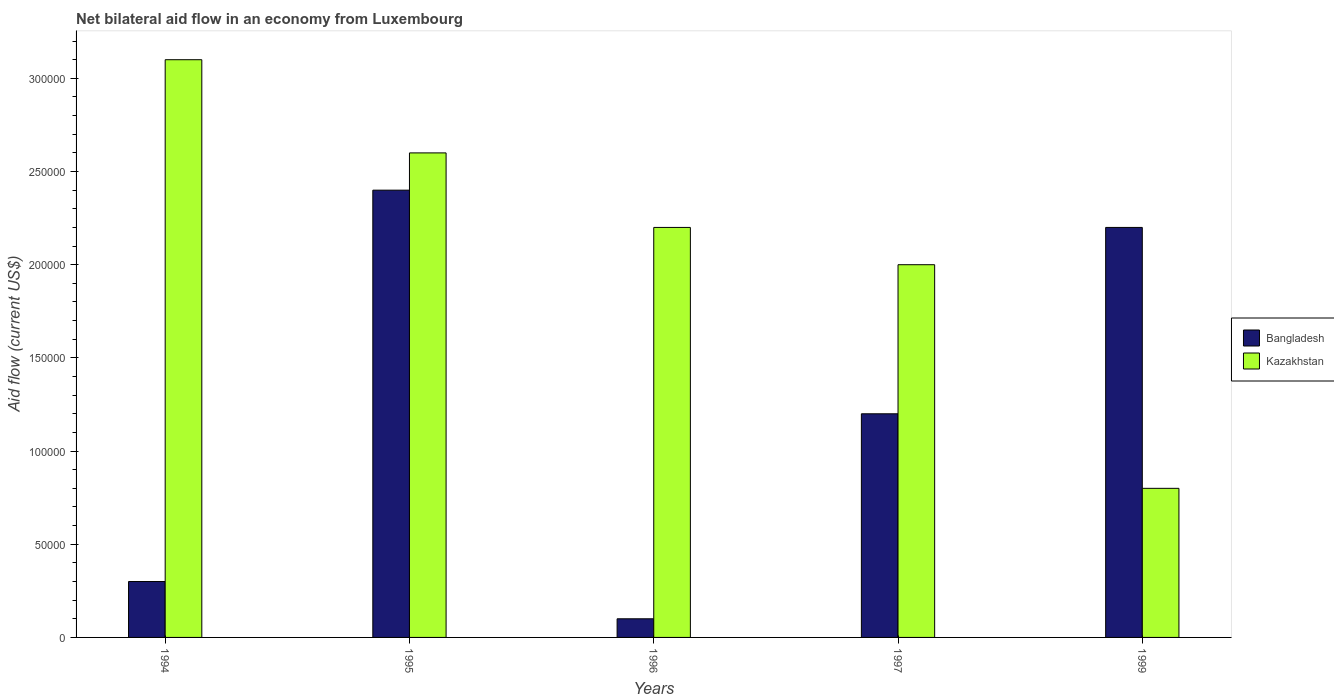How many different coloured bars are there?
Your answer should be very brief. 2. How many groups of bars are there?
Your answer should be very brief. 5. How many bars are there on the 4th tick from the left?
Provide a short and direct response. 2. What is the label of the 4th group of bars from the left?
Give a very brief answer. 1997. Across all years, what is the maximum net bilateral aid flow in Bangladesh?
Your answer should be very brief. 2.40e+05. Across all years, what is the minimum net bilateral aid flow in Bangladesh?
Your response must be concise. 10000. In which year was the net bilateral aid flow in Bangladesh maximum?
Keep it short and to the point. 1995. In which year was the net bilateral aid flow in Kazakhstan minimum?
Your answer should be very brief. 1999. What is the total net bilateral aid flow in Kazakhstan in the graph?
Provide a short and direct response. 1.07e+06. What is the difference between the net bilateral aid flow in Bangladesh in 1997 and the net bilateral aid flow in Kazakhstan in 1994?
Give a very brief answer. -1.90e+05. What is the average net bilateral aid flow in Kazakhstan per year?
Your answer should be very brief. 2.14e+05. In the year 1999, what is the difference between the net bilateral aid flow in Kazakhstan and net bilateral aid flow in Bangladesh?
Give a very brief answer. -1.40e+05. In how many years, is the net bilateral aid flow in Kazakhstan greater than 250000 US$?
Your answer should be very brief. 2. What is the ratio of the net bilateral aid flow in Kazakhstan in 1995 to that in 1996?
Keep it short and to the point. 1.18. What does the 2nd bar from the right in 1995 represents?
Your answer should be compact. Bangladesh. How many years are there in the graph?
Your answer should be very brief. 5. What is the difference between two consecutive major ticks on the Y-axis?
Keep it short and to the point. 5.00e+04. Are the values on the major ticks of Y-axis written in scientific E-notation?
Give a very brief answer. No. Does the graph contain any zero values?
Offer a terse response. No. Where does the legend appear in the graph?
Give a very brief answer. Center right. How are the legend labels stacked?
Offer a terse response. Vertical. What is the title of the graph?
Offer a very short reply. Net bilateral aid flow in an economy from Luxembourg. What is the label or title of the X-axis?
Your response must be concise. Years. What is the Aid flow (current US$) of Bangladesh in 1994?
Provide a short and direct response. 3.00e+04. What is the Aid flow (current US$) in Bangladesh in 1995?
Offer a very short reply. 2.40e+05. What is the Aid flow (current US$) of Kazakhstan in 1996?
Offer a very short reply. 2.20e+05. What is the Aid flow (current US$) in Bangladesh in 1997?
Give a very brief answer. 1.20e+05. What is the Aid flow (current US$) in Kazakhstan in 1999?
Provide a short and direct response. 8.00e+04. Across all years, what is the maximum Aid flow (current US$) in Kazakhstan?
Ensure brevity in your answer.  3.10e+05. Across all years, what is the minimum Aid flow (current US$) of Bangladesh?
Provide a short and direct response. 10000. What is the total Aid flow (current US$) of Bangladesh in the graph?
Give a very brief answer. 6.20e+05. What is the total Aid flow (current US$) in Kazakhstan in the graph?
Your response must be concise. 1.07e+06. What is the difference between the Aid flow (current US$) of Bangladesh in 1994 and that in 1996?
Offer a terse response. 2.00e+04. What is the difference between the Aid flow (current US$) in Kazakhstan in 1994 and that in 1999?
Provide a short and direct response. 2.30e+05. What is the difference between the Aid flow (current US$) of Kazakhstan in 1995 and that in 1996?
Your response must be concise. 4.00e+04. What is the difference between the Aid flow (current US$) of Bangladesh in 1995 and that in 1997?
Give a very brief answer. 1.20e+05. What is the difference between the Aid flow (current US$) in Kazakhstan in 1995 and that in 1999?
Make the answer very short. 1.80e+05. What is the difference between the Aid flow (current US$) of Bangladesh in 1996 and that in 1997?
Offer a terse response. -1.10e+05. What is the difference between the Aid flow (current US$) in Kazakhstan in 1996 and that in 1997?
Your response must be concise. 2.00e+04. What is the difference between the Aid flow (current US$) of Kazakhstan in 1996 and that in 1999?
Offer a very short reply. 1.40e+05. What is the difference between the Aid flow (current US$) of Bangladesh in 1994 and the Aid flow (current US$) of Kazakhstan in 1996?
Your response must be concise. -1.90e+05. What is the difference between the Aid flow (current US$) of Bangladesh in 1994 and the Aid flow (current US$) of Kazakhstan in 1997?
Offer a very short reply. -1.70e+05. What is the difference between the Aid flow (current US$) in Bangladesh in 1996 and the Aid flow (current US$) in Kazakhstan in 1997?
Offer a very short reply. -1.90e+05. What is the difference between the Aid flow (current US$) in Bangladesh in 1996 and the Aid flow (current US$) in Kazakhstan in 1999?
Your answer should be very brief. -7.00e+04. What is the difference between the Aid flow (current US$) in Bangladesh in 1997 and the Aid flow (current US$) in Kazakhstan in 1999?
Provide a short and direct response. 4.00e+04. What is the average Aid flow (current US$) in Bangladesh per year?
Your response must be concise. 1.24e+05. What is the average Aid flow (current US$) in Kazakhstan per year?
Your answer should be very brief. 2.14e+05. In the year 1994, what is the difference between the Aid flow (current US$) in Bangladesh and Aid flow (current US$) in Kazakhstan?
Keep it short and to the point. -2.80e+05. In the year 1996, what is the difference between the Aid flow (current US$) in Bangladesh and Aid flow (current US$) in Kazakhstan?
Offer a terse response. -2.10e+05. In the year 1997, what is the difference between the Aid flow (current US$) in Bangladesh and Aid flow (current US$) in Kazakhstan?
Make the answer very short. -8.00e+04. What is the ratio of the Aid flow (current US$) in Kazakhstan in 1994 to that in 1995?
Provide a succinct answer. 1.19. What is the ratio of the Aid flow (current US$) of Kazakhstan in 1994 to that in 1996?
Your response must be concise. 1.41. What is the ratio of the Aid flow (current US$) of Kazakhstan in 1994 to that in 1997?
Your answer should be compact. 1.55. What is the ratio of the Aid flow (current US$) in Bangladesh in 1994 to that in 1999?
Your response must be concise. 0.14. What is the ratio of the Aid flow (current US$) in Kazakhstan in 1994 to that in 1999?
Give a very brief answer. 3.88. What is the ratio of the Aid flow (current US$) of Kazakhstan in 1995 to that in 1996?
Give a very brief answer. 1.18. What is the ratio of the Aid flow (current US$) of Bangladesh in 1995 to that in 1997?
Ensure brevity in your answer.  2. What is the ratio of the Aid flow (current US$) of Kazakhstan in 1995 to that in 1997?
Provide a succinct answer. 1.3. What is the ratio of the Aid flow (current US$) of Bangladesh in 1995 to that in 1999?
Offer a terse response. 1.09. What is the ratio of the Aid flow (current US$) of Bangladesh in 1996 to that in 1997?
Ensure brevity in your answer.  0.08. What is the ratio of the Aid flow (current US$) in Bangladesh in 1996 to that in 1999?
Offer a terse response. 0.05. What is the ratio of the Aid flow (current US$) of Kazakhstan in 1996 to that in 1999?
Offer a very short reply. 2.75. What is the ratio of the Aid flow (current US$) in Bangladesh in 1997 to that in 1999?
Your answer should be compact. 0.55. What is the ratio of the Aid flow (current US$) of Kazakhstan in 1997 to that in 1999?
Make the answer very short. 2.5. What is the difference between the highest and the lowest Aid flow (current US$) of Bangladesh?
Your answer should be very brief. 2.30e+05. 